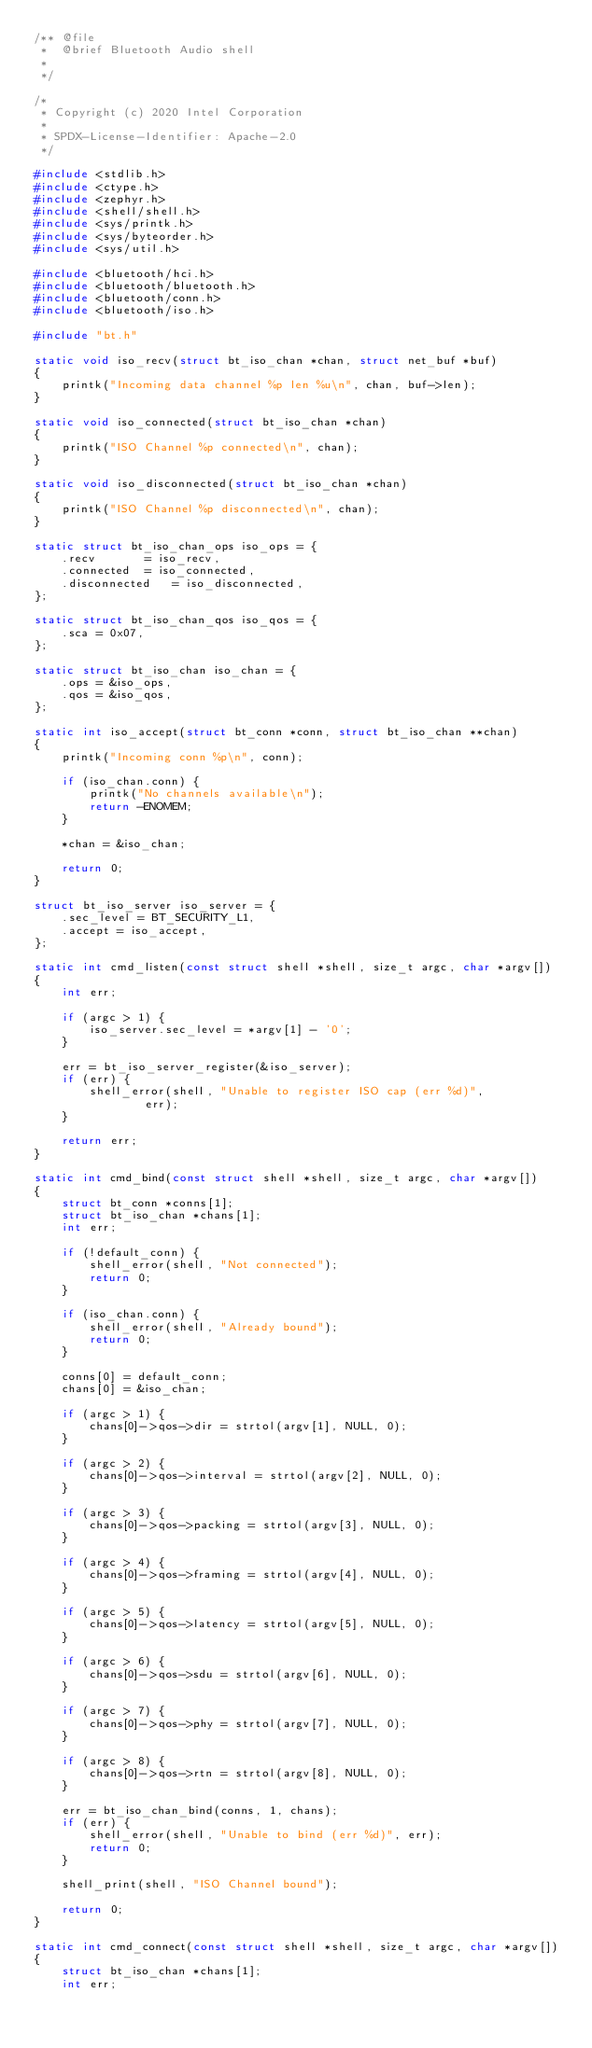<code> <loc_0><loc_0><loc_500><loc_500><_C_>/** @file
 *  @brief Bluetooth Audio shell
 *
 */

/*
 * Copyright (c) 2020 Intel Corporation
 *
 * SPDX-License-Identifier: Apache-2.0
 */

#include <stdlib.h>
#include <ctype.h>
#include <zephyr.h>
#include <shell/shell.h>
#include <sys/printk.h>
#include <sys/byteorder.h>
#include <sys/util.h>

#include <bluetooth/hci.h>
#include <bluetooth/bluetooth.h>
#include <bluetooth/conn.h>
#include <bluetooth/iso.h>

#include "bt.h"

static void iso_recv(struct bt_iso_chan *chan, struct net_buf *buf)
{
	printk("Incoming data channel %p len %u\n", chan, buf->len);
}

static void iso_connected(struct bt_iso_chan *chan)
{
	printk("ISO Channel %p connected\n", chan);
}

static void iso_disconnected(struct bt_iso_chan *chan)
{
	printk("ISO Channel %p disconnected\n", chan);
}

static struct bt_iso_chan_ops iso_ops = {
	.recv		= iso_recv,
	.connected	= iso_connected,
	.disconnected	= iso_disconnected,
};

static struct bt_iso_chan_qos iso_qos = {
	.sca = 0x07,
};

static struct bt_iso_chan iso_chan = {
	.ops = &iso_ops,
	.qos = &iso_qos,
};

static int iso_accept(struct bt_conn *conn, struct bt_iso_chan **chan)
{
	printk("Incoming conn %p\n", conn);

	if (iso_chan.conn) {
		printk("No channels available\n");
		return -ENOMEM;
	}

	*chan = &iso_chan;

	return 0;
}

struct bt_iso_server iso_server = {
	.sec_level = BT_SECURITY_L1,
	.accept = iso_accept,
};

static int cmd_listen(const struct shell *shell, size_t argc, char *argv[])
{
	int err;

	if (argc > 1) {
		iso_server.sec_level = *argv[1] - '0';
	}

	err = bt_iso_server_register(&iso_server);
	if (err) {
		shell_error(shell, "Unable to register ISO cap (err %d)",
			    err);
	}

	return err;
}

static int cmd_bind(const struct shell *shell, size_t argc, char *argv[])
{
	struct bt_conn *conns[1];
	struct bt_iso_chan *chans[1];
	int err;

	if (!default_conn) {
		shell_error(shell, "Not connected");
		return 0;
	}

	if (iso_chan.conn) {
		shell_error(shell, "Already bound");
		return 0;
	}

	conns[0] = default_conn;
	chans[0] = &iso_chan;

	if (argc > 1) {
		chans[0]->qos->dir = strtol(argv[1], NULL, 0);
	}

	if (argc > 2) {
		chans[0]->qos->interval = strtol(argv[2], NULL, 0);
	}

	if (argc > 3) {
		chans[0]->qos->packing = strtol(argv[3], NULL, 0);
	}

	if (argc > 4) {
		chans[0]->qos->framing = strtol(argv[4], NULL, 0);
	}

	if (argc > 5) {
		chans[0]->qos->latency = strtol(argv[5], NULL, 0);
	}

	if (argc > 6) {
		chans[0]->qos->sdu = strtol(argv[6], NULL, 0);
	}

	if (argc > 7) {
		chans[0]->qos->phy = strtol(argv[7], NULL, 0);
	}

	if (argc > 8) {
		chans[0]->qos->rtn = strtol(argv[8], NULL, 0);
	}

	err = bt_iso_chan_bind(conns, 1, chans);
	if (err) {
		shell_error(shell, "Unable to bind (err %d)", err);
		return 0;
	}

	shell_print(shell, "ISO Channel bound");

	return 0;
}

static int cmd_connect(const struct shell *shell, size_t argc, char *argv[])
{
	struct bt_iso_chan *chans[1];
	int err;
</code> 